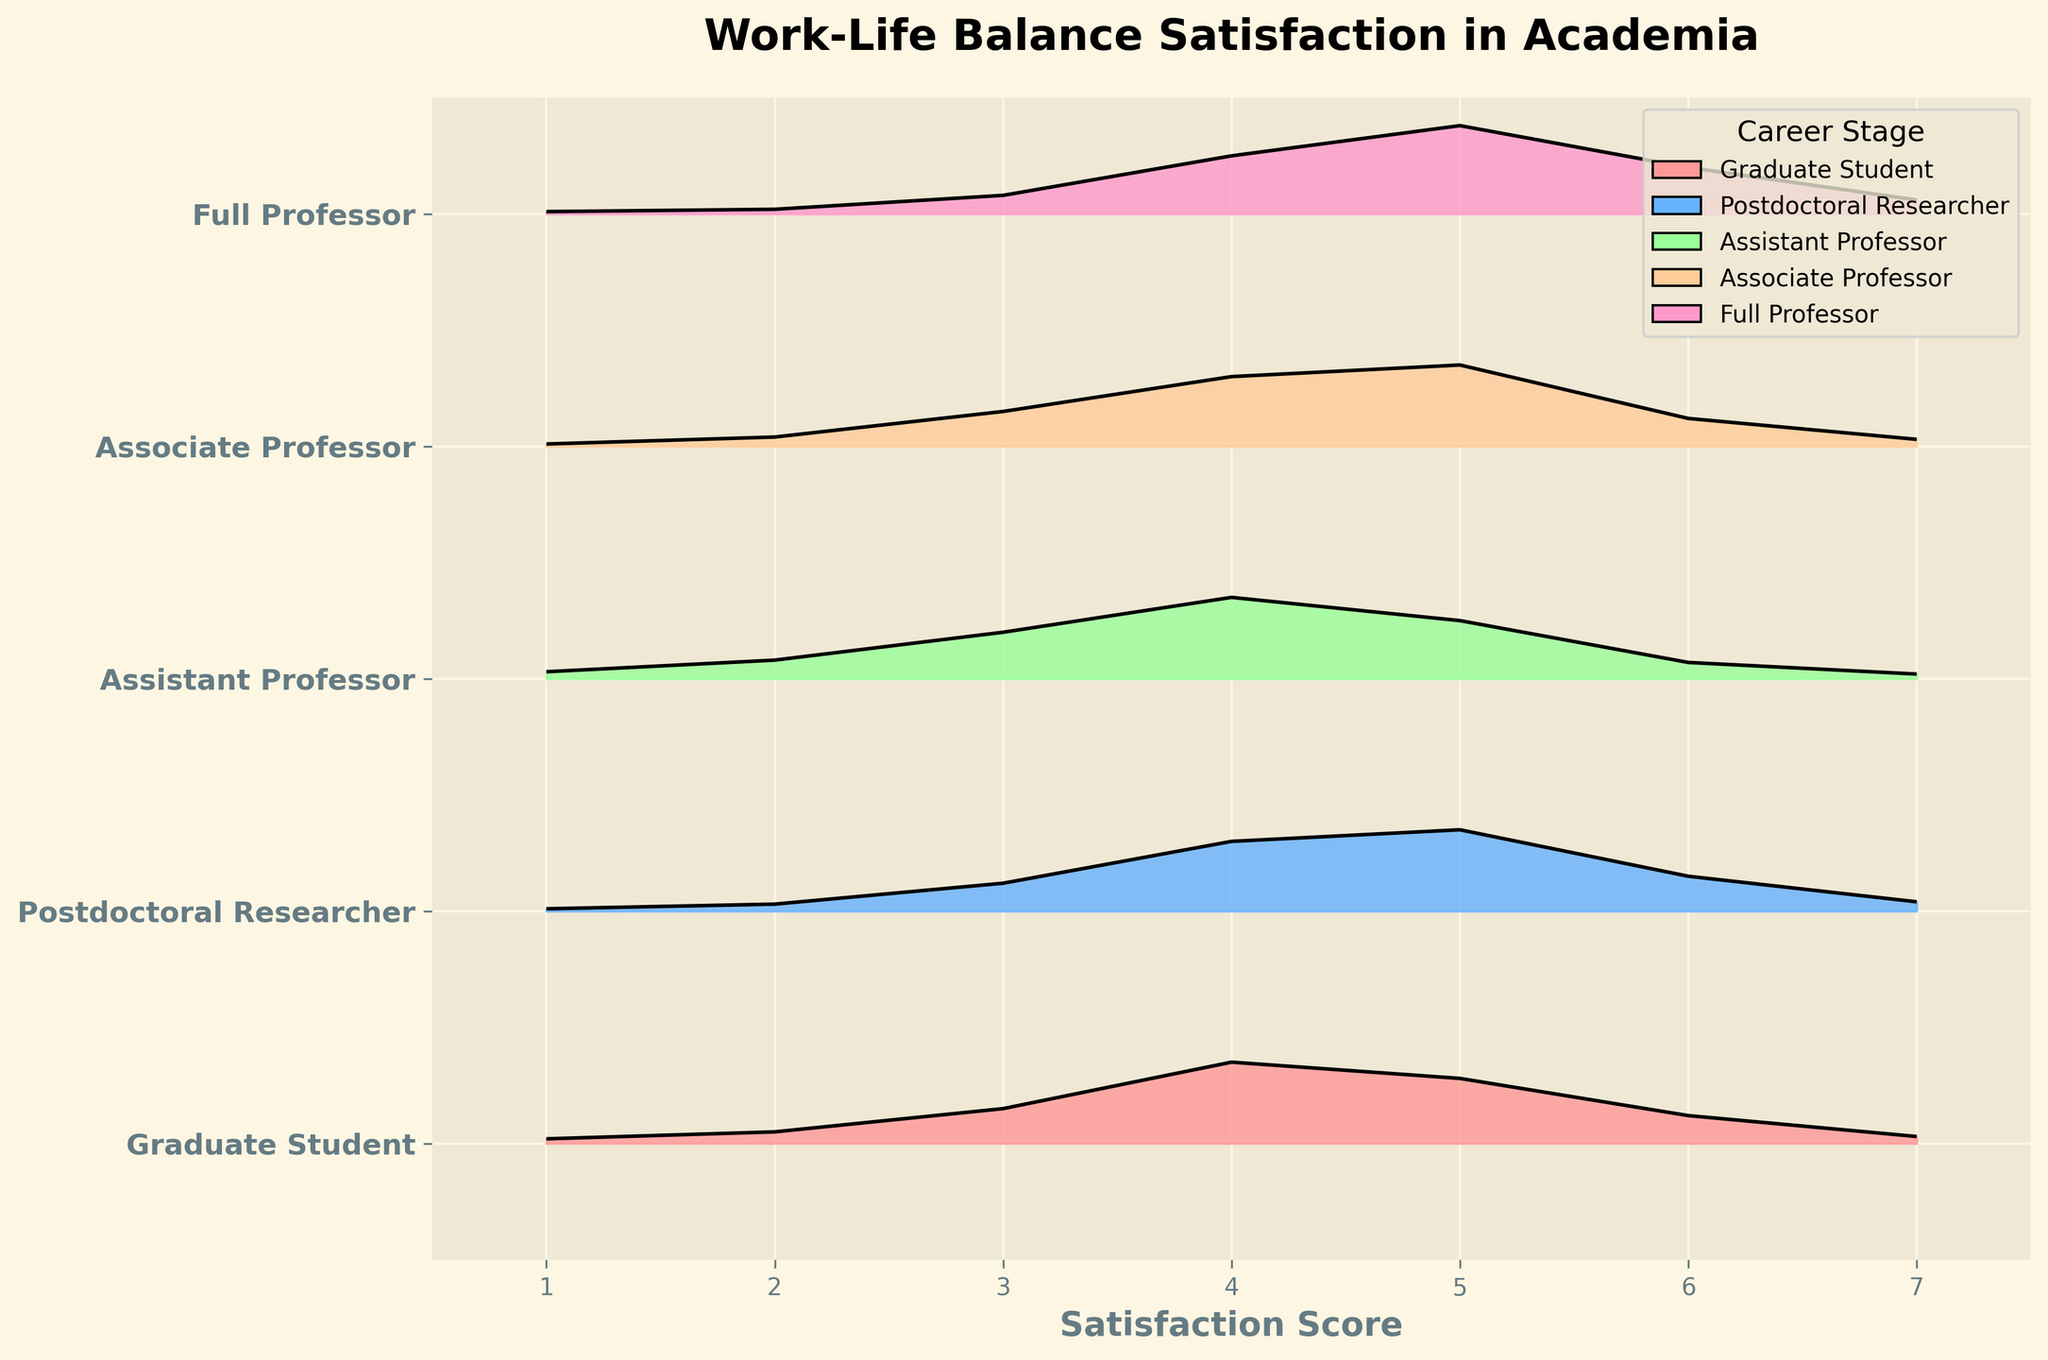What is the title of the plot? The title of the plot is usually placed at the top of the figure in a larger or bold font to indicate the main topic of the graph. In this case, the title is "Work-Life Balance Satisfaction in Academia."
Answer: Work-Life Balance Satisfaction in Academia Which career stage has the highest density for a satisfaction score of 5? By observing the density values at a satisfaction score of 5 for each career stage, we can see which one has the highest value. The Full Professor stage has the highest density of 0.38 for a satisfaction score of 5.
Answer: Full Professor What is the x-axis label? The label for the x-axis in the plot typically describes the variable being plotted on the x-axis. Here, it indicates the satisfaction score, labeled as "Satisfaction Score."
Answer: Satisfaction Score For which career stage is the density value for a satisfaction score of 6 the lowest? By comparing the density values at a satisfaction score of 6 across all career stages, we can see the lowest value of 0.07 is for Assistant Professors.
Answer: Assistant Professor Compare the most common satisfaction score between Graduate Students and Postdoctoral Researchers. Which group has a higher peak density at their most common score? By examining the plot, the most common satisfaction score (highest peak) for Graduate Students is 4 with a density of 0.35. Postdoctoral Researchers also have their peak at 4 with a density of 0.35. Both groups have the same peak density at their most common score.
Answer: Both What is the range of satisfaction scores shown in the plot? The satisfaction scores on the x-axis range from the minimum to the maximum values shown in the plot. Here, they range from 1 to 7.
Answer: 1 to 7 Which career stage has the lowest density for a satisfaction score of 1? By checking the density for a satisfaction score of 1 across all career stages, Postdoctoral Researchers have the lowest value with a density of 0.01.
Answer: Postdoctoral Researcher How do the density curves for satisfaction scores of Assistant Professors and Associate Professors compare between scores 4 and 5? The densities for scores of 4 and 5 for both career stages need to be compared. Assistant Professors have densities of 0.35 for 4 and 0.25 for 5. Associate Professors have 0.30 for 4 and 0.35 for 5. Thus, the densities for 4 and 5 switch positions between the two stages.
Answer: They're reversed; higher at 4 for Assistant Professors and higher at 5 for Associate Professors What is the most common satisfaction score for Full Professors? By examining the plot, we can see that for Full Professors, the highest peak density is at a satisfaction score of 5.
Answer: 5 